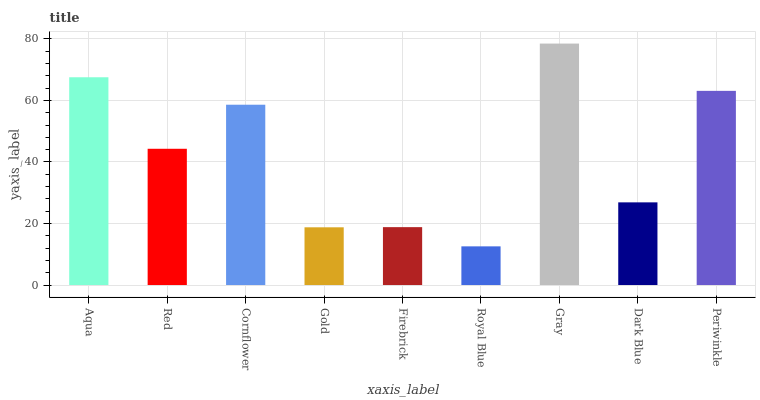Is Royal Blue the minimum?
Answer yes or no. Yes. Is Gray the maximum?
Answer yes or no. Yes. Is Red the minimum?
Answer yes or no. No. Is Red the maximum?
Answer yes or no. No. Is Aqua greater than Red?
Answer yes or no. Yes. Is Red less than Aqua?
Answer yes or no. Yes. Is Red greater than Aqua?
Answer yes or no. No. Is Aqua less than Red?
Answer yes or no. No. Is Red the high median?
Answer yes or no. Yes. Is Red the low median?
Answer yes or no. Yes. Is Cornflower the high median?
Answer yes or no. No. Is Periwinkle the low median?
Answer yes or no. No. 